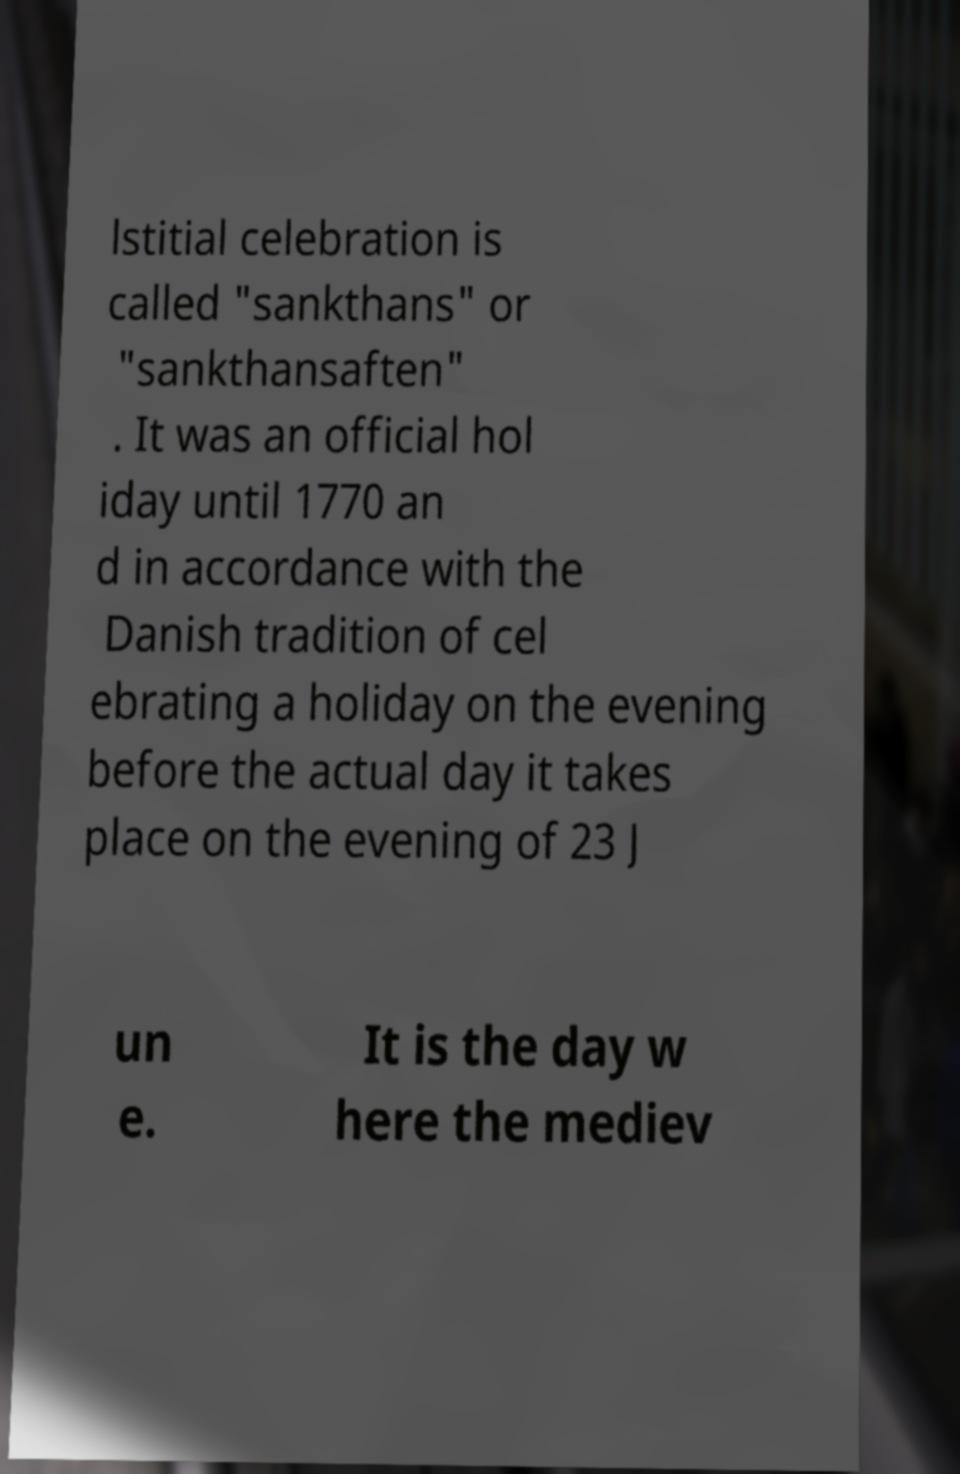There's text embedded in this image that I need extracted. Can you transcribe it verbatim? lstitial celebration is called "sankthans" or "sankthansaften" . It was an official hol iday until 1770 an d in accordance with the Danish tradition of cel ebrating a holiday on the evening before the actual day it takes place on the evening of 23 J un e. It is the day w here the mediev 